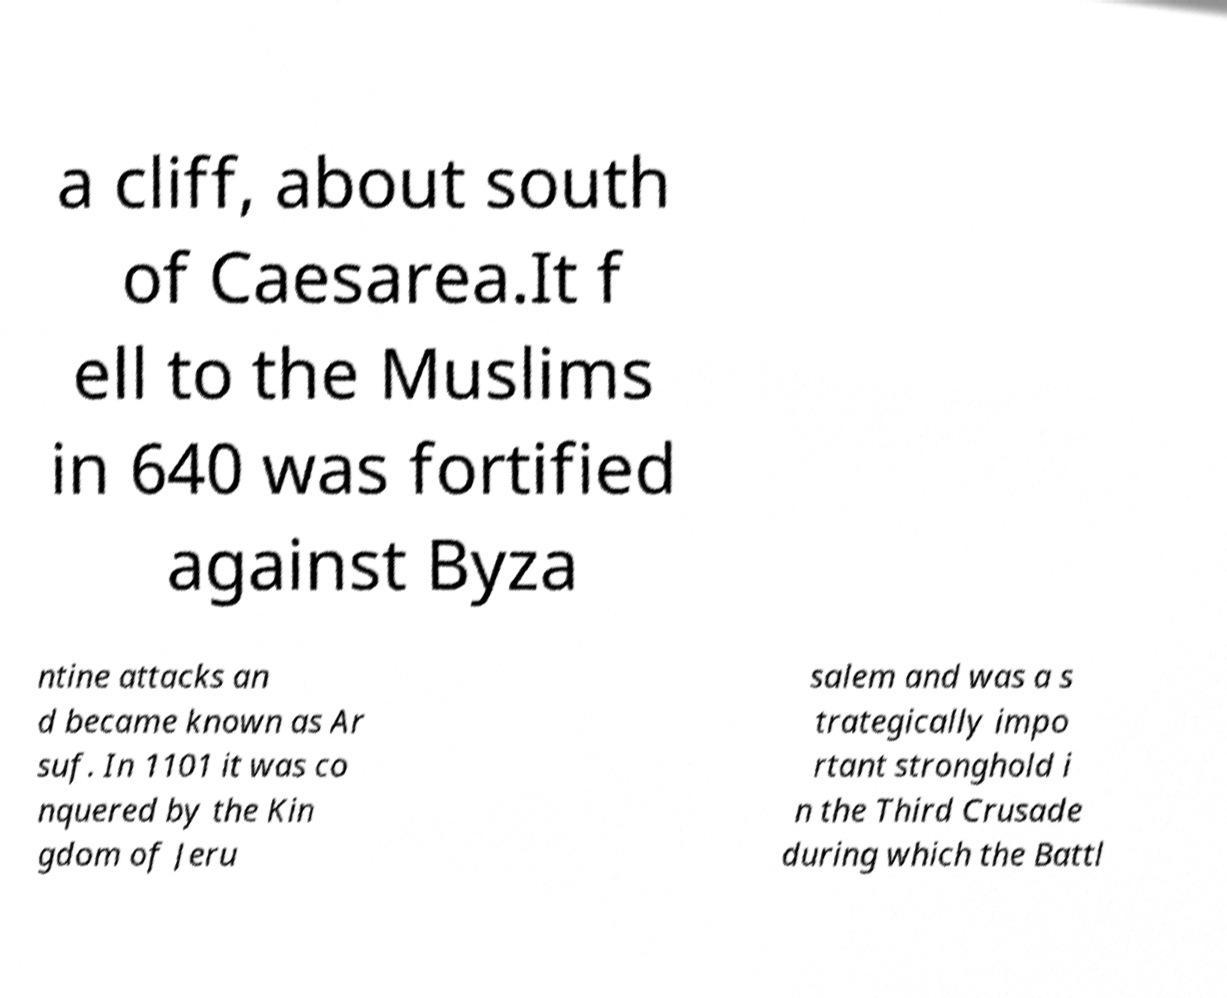There's text embedded in this image that I need extracted. Can you transcribe it verbatim? a cliff, about south of Caesarea.It f ell to the Muslims in 640 was fortified against Byza ntine attacks an d became known as Ar suf. In 1101 it was co nquered by the Kin gdom of Jeru salem and was a s trategically impo rtant stronghold i n the Third Crusade during which the Battl 